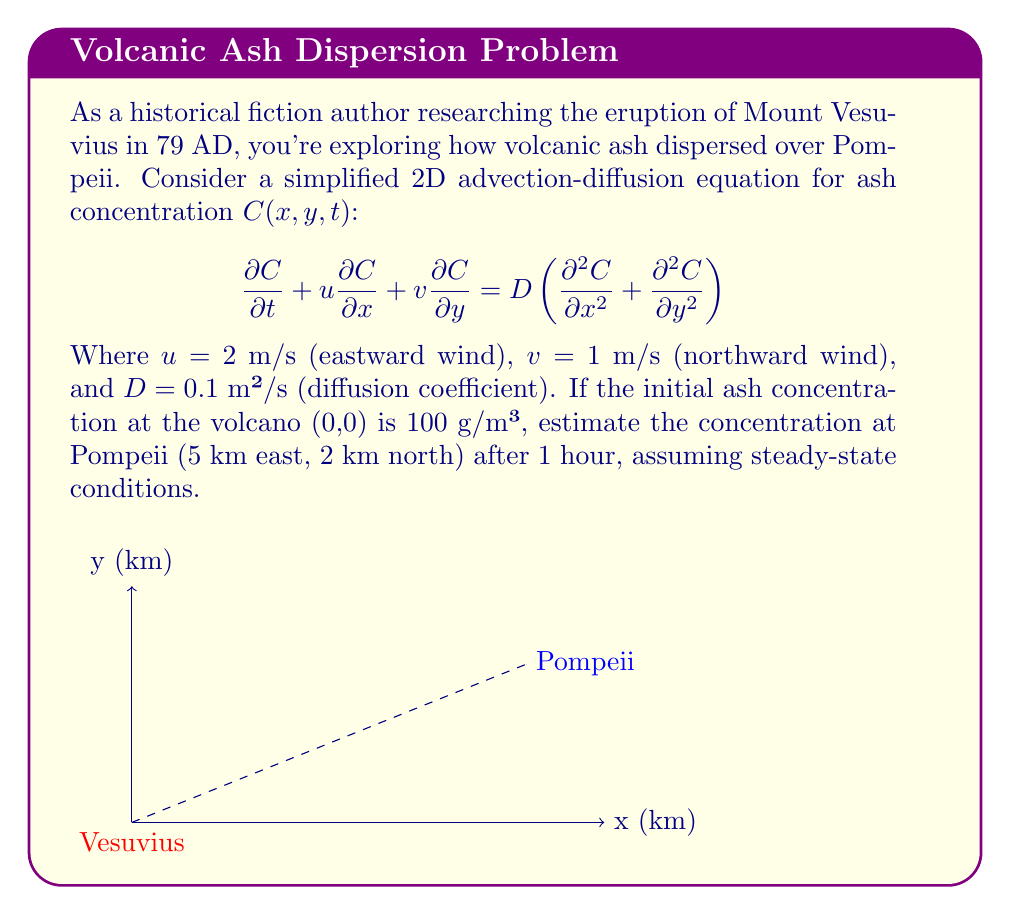What is the answer to this math problem? To solve this problem, we'll use the steady-state advection-diffusion equation and apply the given parameters:

1) For steady-state, $\frac{\partial C}{\partial t} = 0$, so our equation becomes:

   $$u\frac{\partial C}{\partial x} + v\frac{\partial C}{\partial y} = D\left(\frac{\partial^2 C}{\partial x^2} + \frac{\partial^2 C}{\partial y^2}\right)$$

2) The solution for a point source in 2D steady-state advection-diffusion is:

   $$C(x,y) = \frac{Q}{4\pi D} \exp\left(\frac{u(x-x_0)+v(y-y_0)}{2D} - \frac{\sqrt{u^2+v^2}\sqrt{(x-x_0)^2+(y-y_0)^2}}{2D}\right)$$

   Where $(x_0,y_0)$ is the source location and $Q$ is the source strength.

3) Given parameters:
   - $u = 2$ m/s
   - $v = 1$ m/s
   - $D = 0.1$ m²/s
   - $(x_0,y_0) = (0,0)$
   - $(x,y) = (5000,2000)$ m (Pompeii's location)
   - $Q = 100$ g/m³ * $4\pi D$ (to normalize the equation)

4) Substituting these values:

   $$C(5000,2000) = 100 \exp\left(\frac{2(5000)+1(2000)}{2(0.1)} - \frac{\sqrt{2^2+1^2}\sqrt{5000^2+2000^2}}{2(0.1)}\right)$$

5) Simplifying:
   
   $$C(5000,2000) = 100 \exp\left(60000 - 67082.04\right)$$
   
   $$C(5000,2000) = 100 \exp(-7082.04)$$

6) Calculating the final result:

   $$C(5000,2000) \approx 0$$

The concentration is effectively zero due to the large negative exponent.
Answer: $0$ g/m³ 